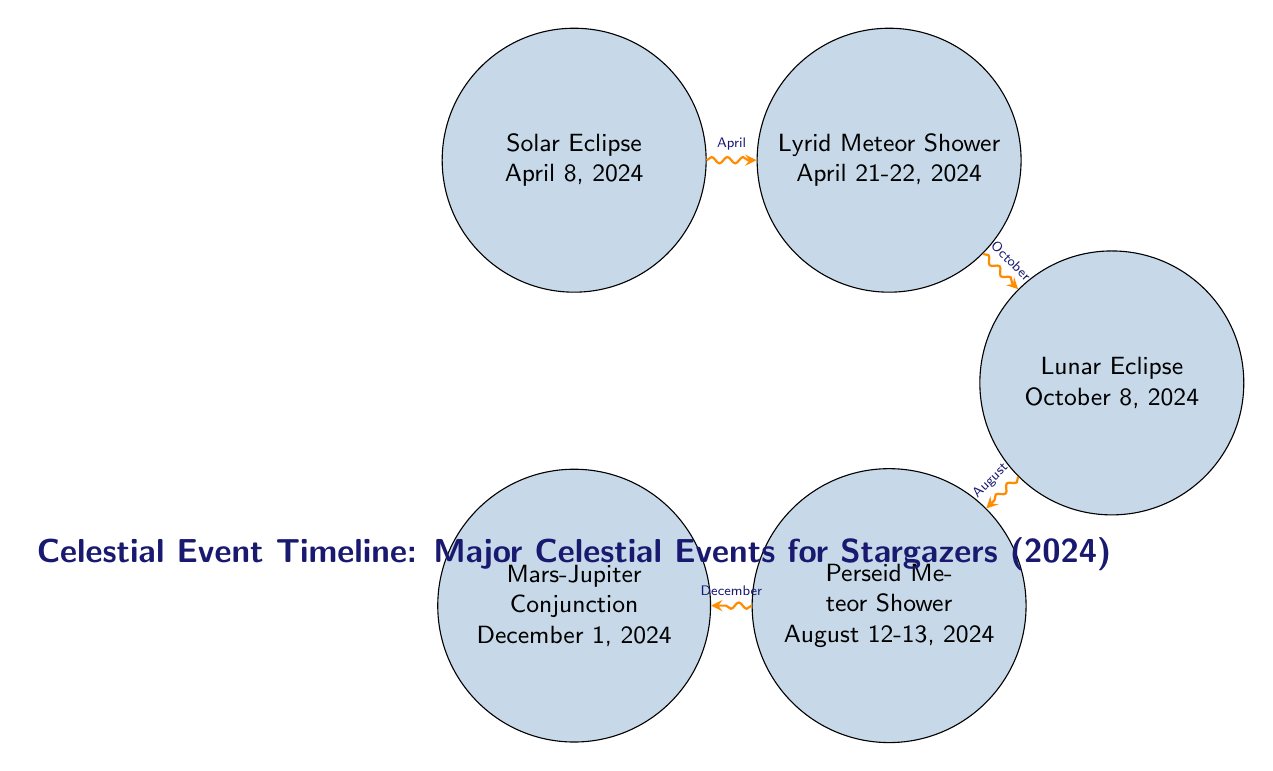What is the first event in the timeline? The diagram clearly lists the first event at the top left, which is the Solar Eclipse occurring on April 8, 2024.
Answer: Solar Eclipse What event occurs immediately after the Lyrid Meteor Shower? By following the arrows in the diagram, it shows that the event immediately after the Lyrid Meteor Shower is the Lunar Eclipse on October 8, 2024.
Answer: Lunar Eclipse How many celestial events are shown in the diagram? By counting the nodes in the diagram, we find there are a total of five distinct celestial events represented.
Answer: 5 What significant event happens in August? The timeline indicates the Perseid Meteor Shower occurs in August, specifically on August 12-13, 2024.
Answer: Perseid Meteor Shower Which two events are months apart? Analyzing the timeline, we notice that there is a significant gap between the Perseid Meteor Shower in August and the Mars-Jupiter Conjunction in December, indicating they are months apart.
Answer: Perseid Meteor Shower and Mars-Jupiter Conjunction What type of celestial event is on December 1, 2024? The diagram labels the event on December 1, 2024, as a conjunction, specifically between Mars and Jupiter.
Answer: Mars-Jupiter Conjunction What is the flow of events starting from the Solar Eclipse? Starting from the Solar Eclipse in April, it flows to the Lyrid Meteor Shower in late April, then to the Lunar Eclipse in October, followed by the Perseid Meteor Shower in August, and finally culminating in the Mars-Jupiter Conjunction in December.
Answer: Solar Eclipse → Lyrid Meteor Shower → Lunar Eclipse → Perseid Meteor Shower → Mars-Jupiter Conjunction Which month features a lunar event? The only lunar event indicated in the diagram is the Lunar Eclipse, which is scheduled for October.
Answer: October 